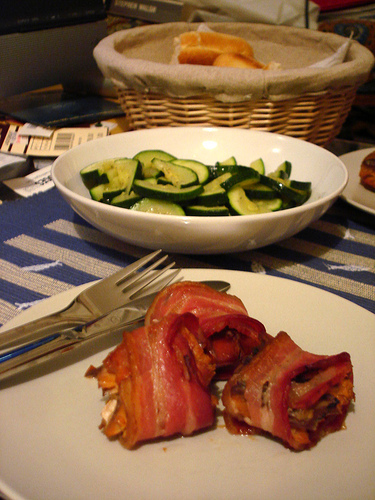<image>
Is there a fork on the plate? Yes. Looking at the image, I can see the fork is positioned on top of the plate, with the plate providing support. Is the cucumber on the plate? No. The cucumber is not positioned on the plate. They may be near each other, but the cucumber is not supported by or resting on top of the plate. Where is the food in relation to the plate? Is it on the plate? No. The food is not positioned on the plate. They may be near each other, but the food is not supported by or resting on top of the plate. Is the fork in front of the basket? Yes. The fork is positioned in front of the basket, appearing closer to the camera viewpoint. Is there a squash above the silver? No. The squash is not positioned above the silver. The vertical arrangement shows a different relationship. 